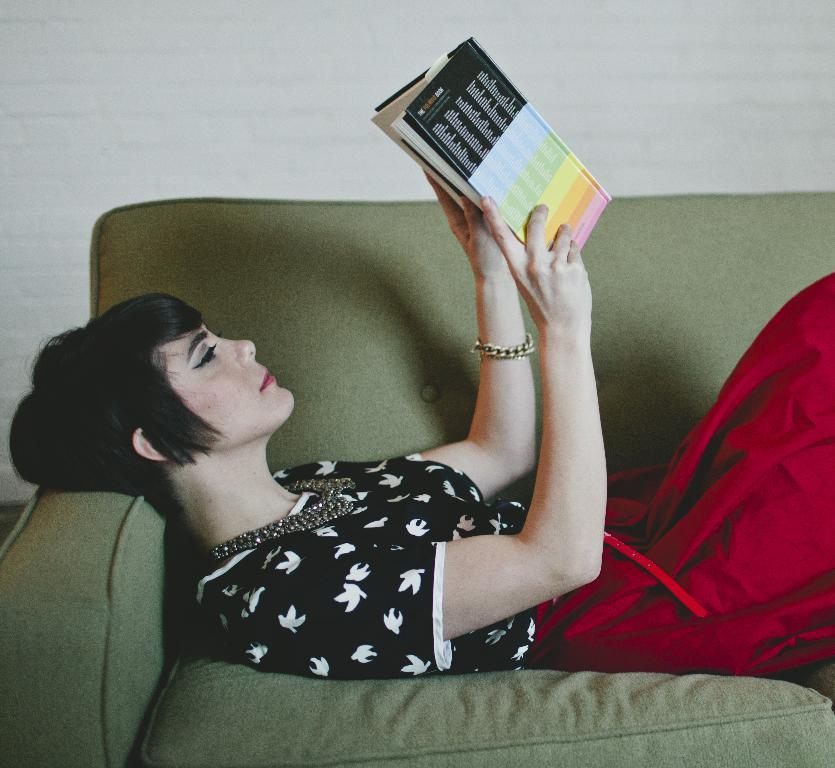Where was the image taken? The image is taken inside a room. Who is present in the image? There is a woman in the image. What is the woman doing in the image? The woman is lying on a couch. What is the woman holding in her hand? The woman is holding a book in her hand. What can be seen in the background of the image? There is a wall visible in the background of the image. What type of drum can be seen in the image? There is no drum present in the image. Is the woman driving a car in the image? No, the woman is lying on a couch and not driving a car in the image. 